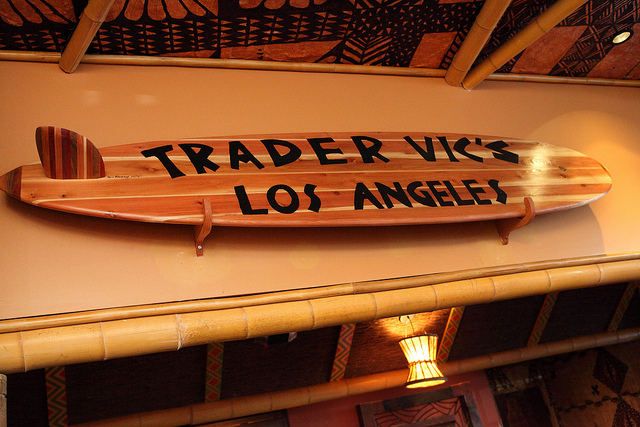Read and extract the text from this image. LOS ANGELES VICS TRADER 